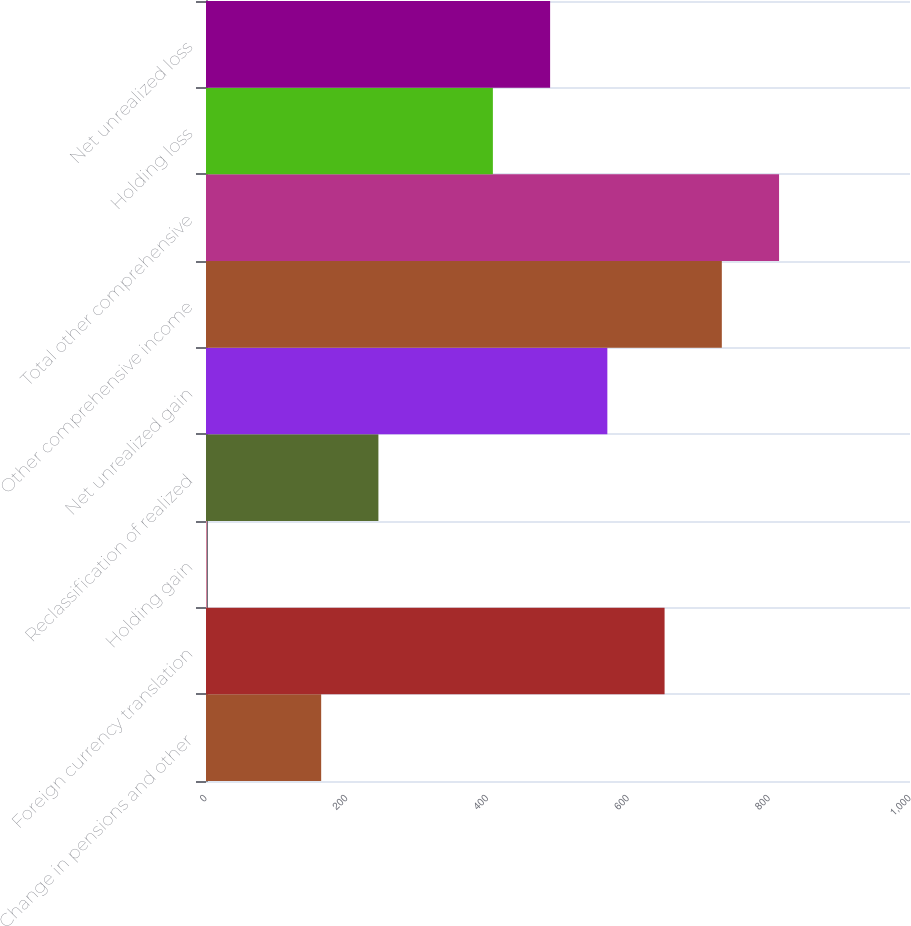Convert chart. <chart><loc_0><loc_0><loc_500><loc_500><bar_chart><fcel>Change in pensions and other<fcel>Foreign currency translation<fcel>Holding gain<fcel>Reclassification of realized<fcel>Net unrealized gain<fcel>Other comprehensive income<fcel>Total other comprehensive<fcel>Holding loss<fcel>Net unrealized loss<nl><fcel>163.6<fcel>651.4<fcel>1<fcel>244.9<fcel>570.1<fcel>732.7<fcel>814<fcel>407.5<fcel>488.8<nl></chart> 